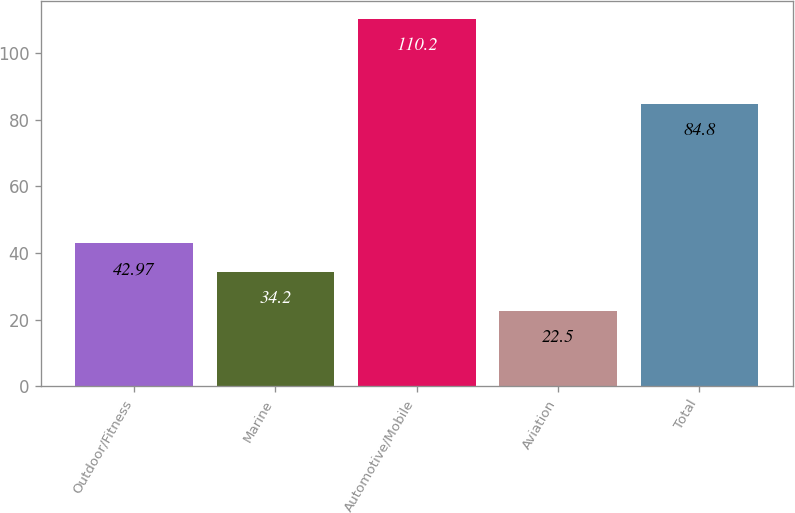Convert chart. <chart><loc_0><loc_0><loc_500><loc_500><bar_chart><fcel>Outdoor/Fitness<fcel>Marine<fcel>Automotive/Mobile<fcel>Aviation<fcel>Total<nl><fcel>42.97<fcel>34.2<fcel>110.2<fcel>22.5<fcel>84.8<nl></chart> 